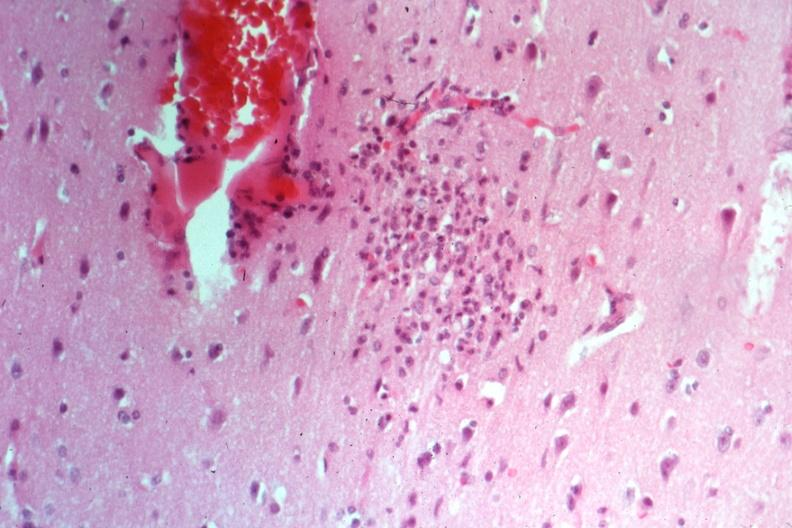what is present?
Answer the question using a single word or phrase. Brain 